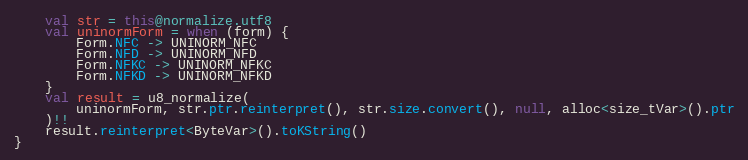Convert code to text. <code><loc_0><loc_0><loc_500><loc_500><_Kotlin_>    val str = this@normalize.utf8
    val uninormForm = when (form) {
        Form.NFC -> UNINORM_NFC
        Form.NFD -> UNINORM_NFD
        Form.NFKC -> UNINORM_NFKC
        Form.NFKD -> UNINORM_NFKD
    }
    val result = u8_normalize(
        uninormForm, str.ptr.reinterpret(), str.size.convert(), null, alloc<size_tVar>().ptr
    )!!
    result.reinterpret<ByteVar>().toKString()
}
</code> 